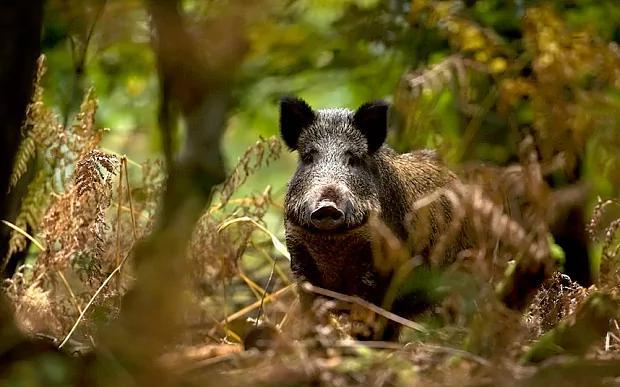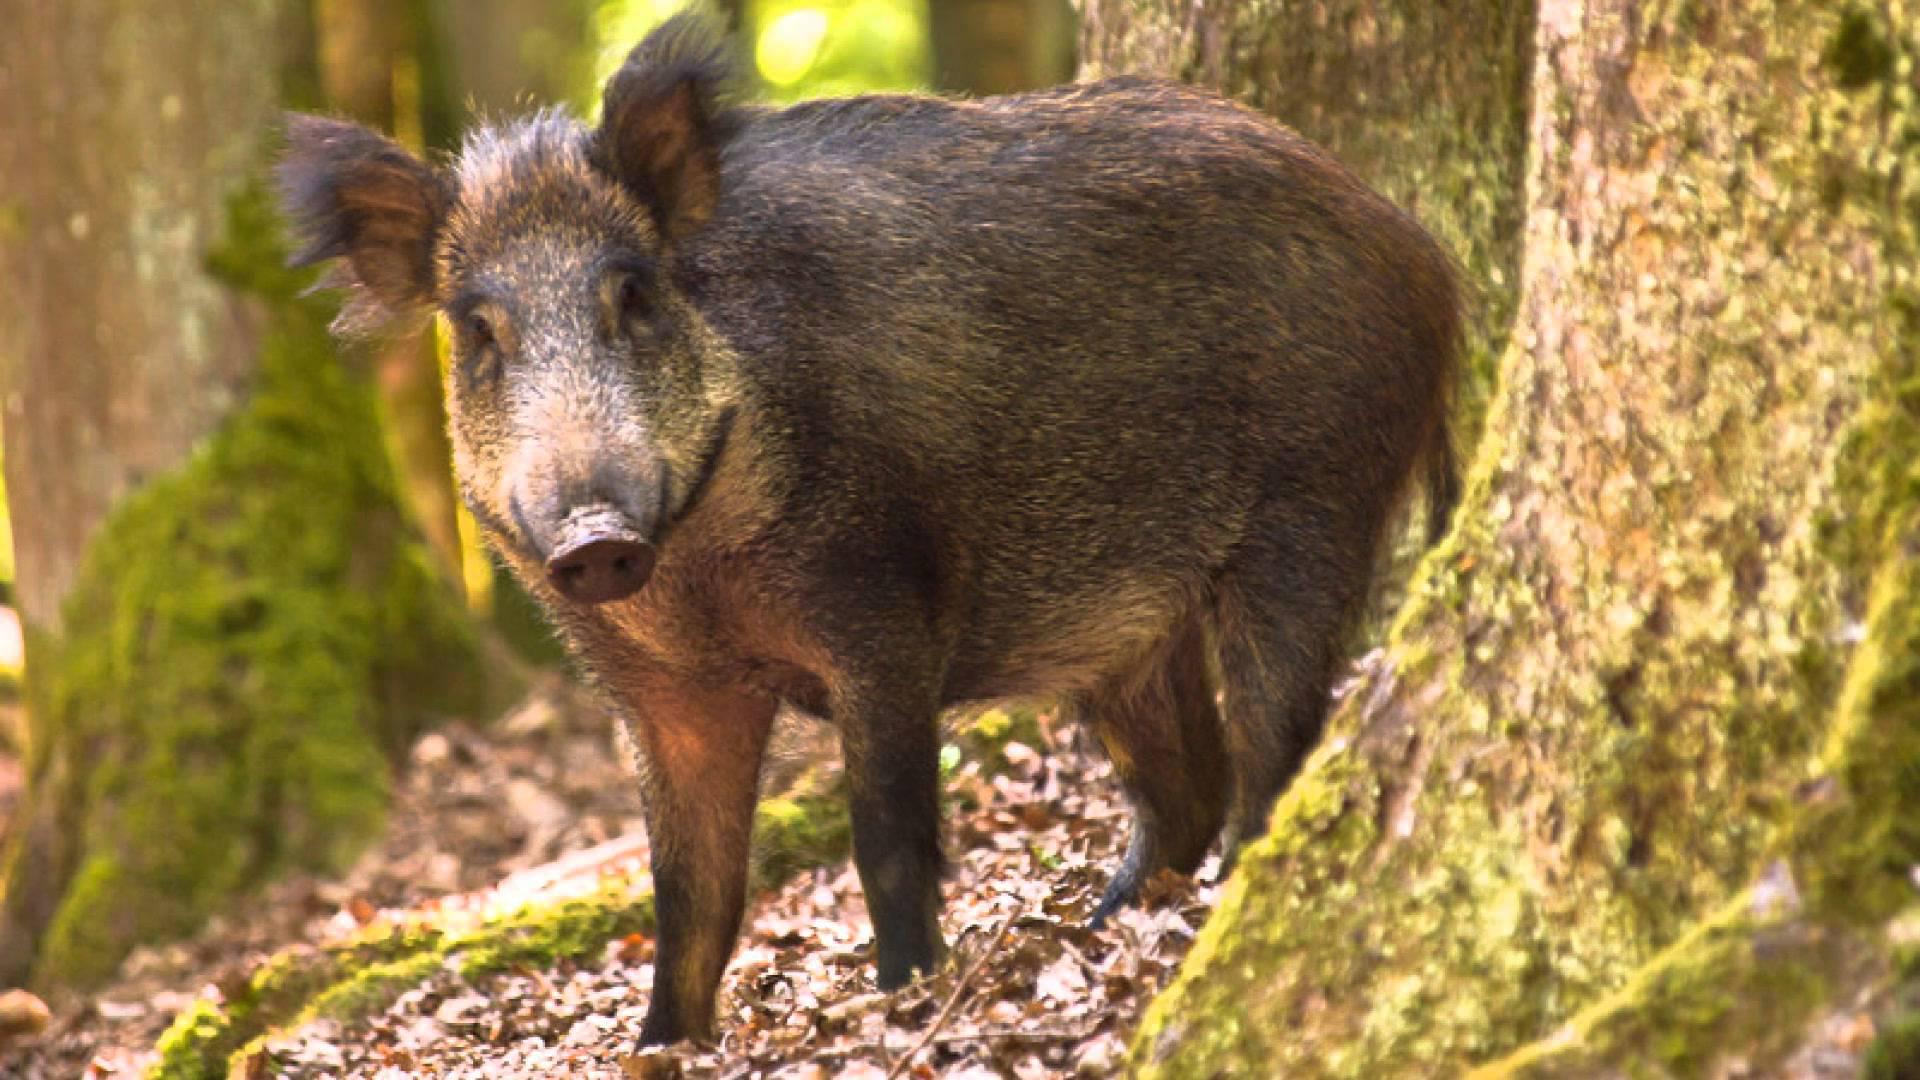The first image is the image on the left, the second image is the image on the right. Evaluate the accuracy of this statement regarding the images: "There are two hogs in total.". Is it true? Answer yes or no. Yes. The first image is the image on the left, the second image is the image on the right. Examine the images to the left and right. Is the description "One image shows a single adult pig in profile, and the other image includes at least one adult wild pig with two smaller piglets." accurate? Answer yes or no. No. 